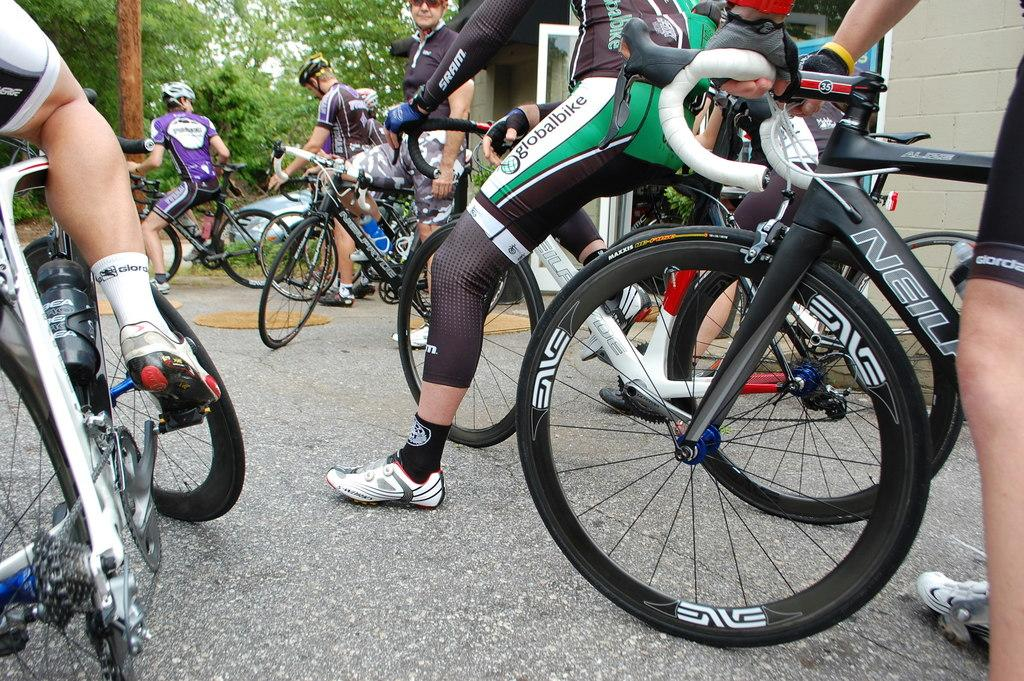What are the people in the image doing? The people in the image are riding bicycles. What is at the bottom of the image? There is a road at the bottom of the image. What can be seen in the background of the image? There are trees in the background of the image. Where is the lock located in the image? There is no lock present in the image. How many people are in the crowd in the image? There is no crowd present in the image; it features people riding bicycles individually or in small groups. 